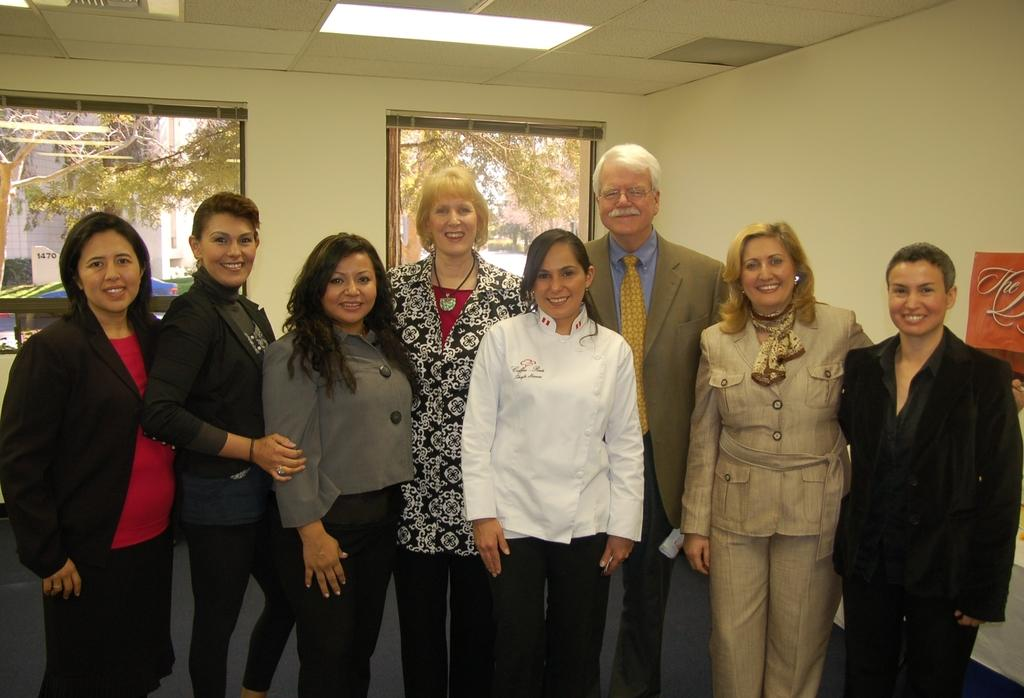What is happening with the group of people in the image? The people are standing and posing for a photo in the image. What can be seen in the background of the image? There are two windows and a wall visible in the background. What type of branch is being used for treatment in the image? There is no branch or treatment present in the image; it features a group of people posing for a photo. How many birds can be seen flying in the image? There are no birds visible in the image. 